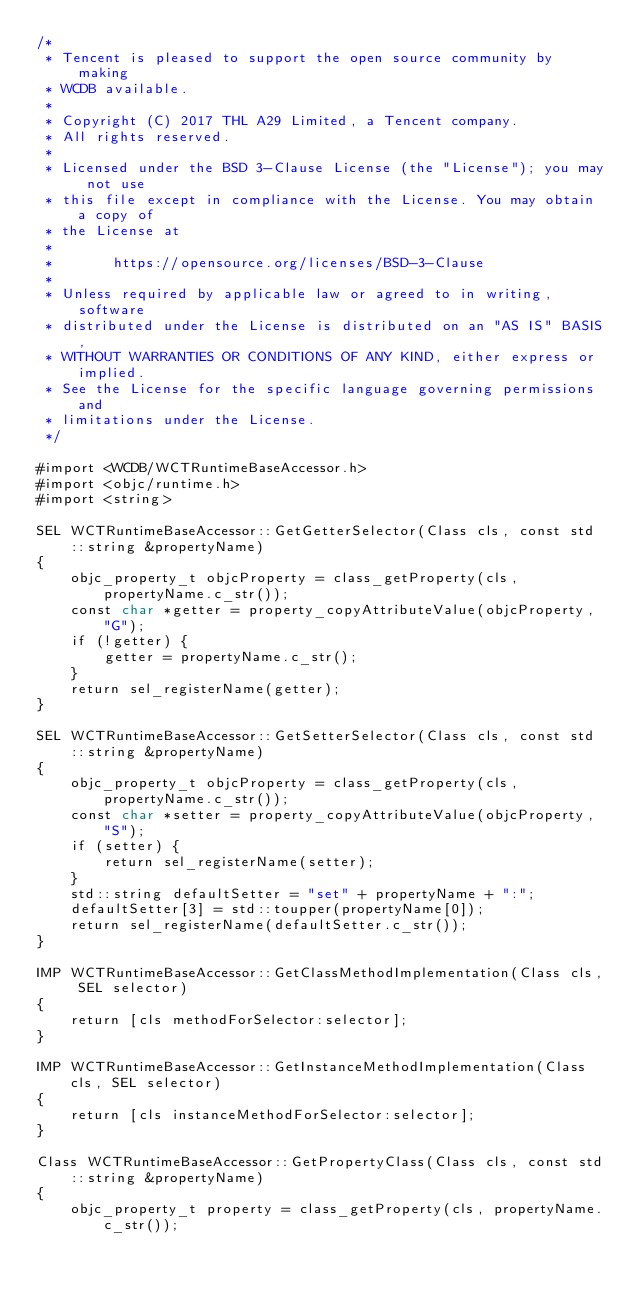<code> <loc_0><loc_0><loc_500><loc_500><_ObjectiveC_>/*
 * Tencent is pleased to support the open source community by making
 * WCDB available.
 *
 * Copyright (C) 2017 THL A29 Limited, a Tencent company.
 * All rights reserved.
 *
 * Licensed under the BSD 3-Clause License (the "License"); you may not use
 * this file except in compliance with the License. You may obtain a copy of
 * the License at
 *
 *       https://opensource.org/licenses/BSD-3-Clause
 *
 * Unless required by applicable law or agreed to in writing, software
 * distributed under the License is distributed on an "AS IS" BASIS,
 * WITHOUT WARRANTIES OR CONDITIONS OF ANY KIND, either express or implied.
 * See the License for the specific language governing permissions and
 * limitations under the License.
 */

#import <WCDB/WCTRuntimeBaseAccessor.h>
#import <objc/runtime.h>
#import <string>

SEL WCTRuntimeBaseAccessor::GetGetterSelector(Class cls, const std::string &propertyName)
{
    objc_property_t objcProperty = class_getProperty(cls, propertyName.c_str());
    const char *getter = property_copyAttributeValue(objcProperty, "G");
    if (!getter) {
        getter = propertyName.c_str();
    }
    return sel_registerName(getter);
}

SEL WCTRuntimeBaseAccessor::GetSetterSelector(Class cls, const std::string &propertyName)
{
    objc_property_t objcProperty = class_getProperty(cls, propertyName.c_str());
    const char *setter = property_copyAttributeValue(objcProperty, "S");
    if (setter) {
        return sel_registerName(setter);
    }
    std::string defaultSetter = "set" + propertyName + ":";
    defaultSetter[3] = std::toupper(propertyName[0]);
    return sel_registerName(defaultSetter.c_str());
}

IMP WCTRuntimeBaseAccessor::GetClassMethodImplementation(Class cls, SEL selector)
{
    return [cls methodForSelector:selector];
}

IMP WCTRuntimeBaseAccessor::GetInstanceMethodImplementation(Class cls, SEL selector)
{
    return [cls instanceMethodForSelector:selector];
}

Class WCTRuntimeBaseAccessor::GetPropertyClass(Class cls, const std::string &propertyName)
{
    objc_property_t property = class_getProperty(cls, propertyName.c_str());</code> 